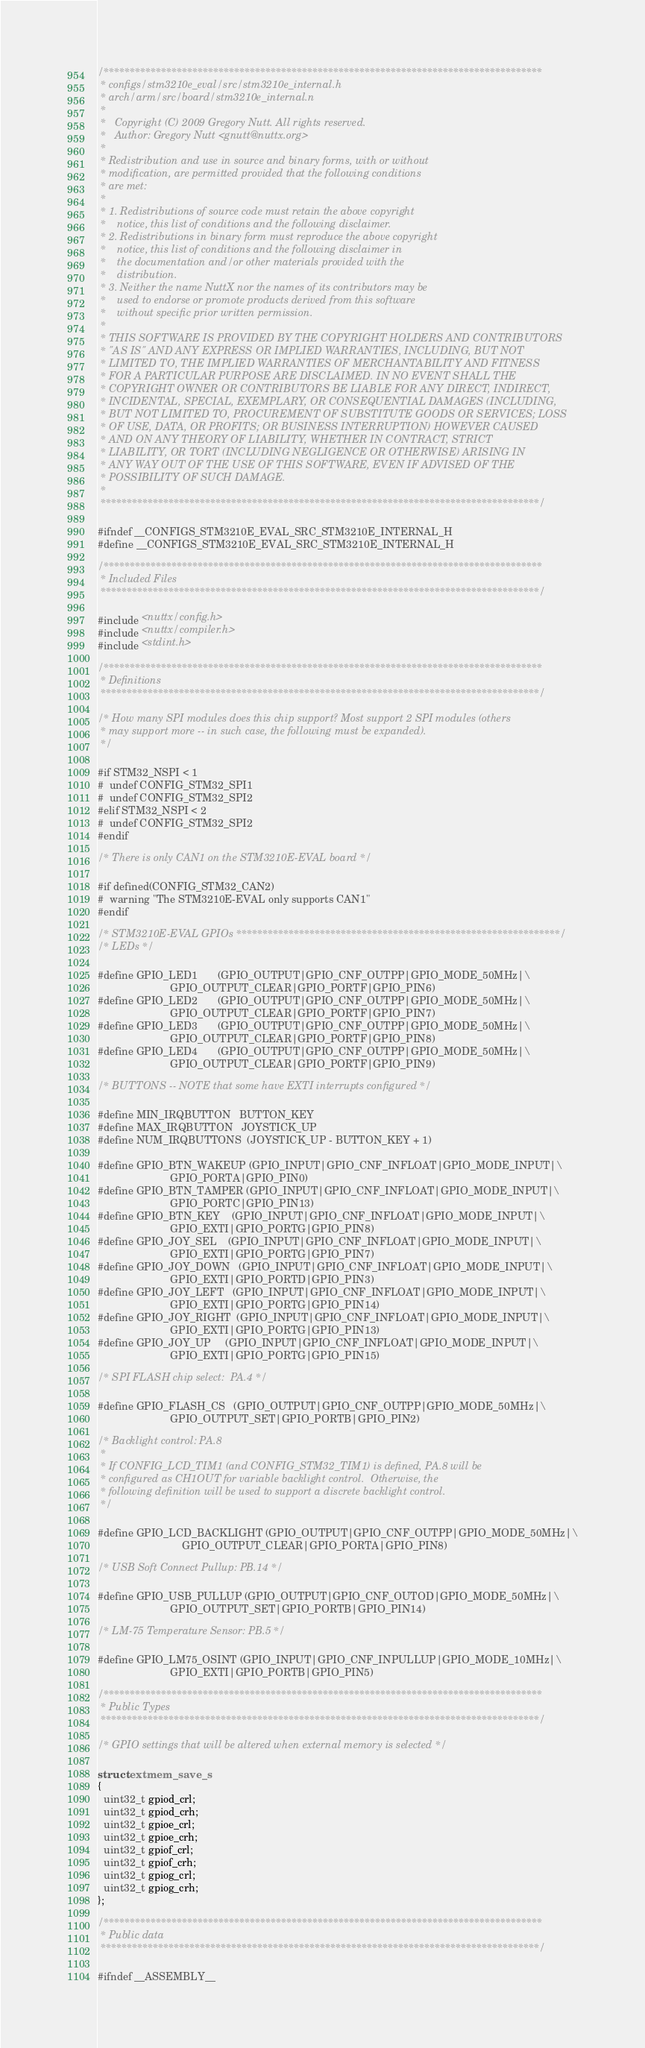<code> <loc_0><loc_0><loc_500><loc_500><_C_>/************************************************************************************
 * configs/stm3210e_eval/src/stm3210e_internal.h
 * arch/arm/src/board/stm3210e_internal.n
 *
 *   Copyright (C) 2009 Gregory Nutt. All rights reserved.
 *   Author: Gregory Nutt <gnutt@nuttx.org>
 *
 * Redistribution and use in source and binary forms, with or without
 * modification, are permitted provided that the following conditions
 * are met:
 *
 * 1. Redistributions of source code must retain the above copyright
 *    notice, this list of conditions and the following disclaimer.
 * 2. Redistributions in binary form must reproduce the above copyright
 *    notice, this list of conditions and the following disclaimer in
 *    the documentation and/or other materials provided with the
 *    distribution.
 * 3. Neither the name NuttX nor the names of its contributors may be
 *    used to endorse or promote products derived from this software
 *    without specific prior written permission.
 *
 * THIS SOFTWARE IS PROVIDED BY THE COPYRIGHT HOLDERS AND CONTRIBUTORS
 * "AS IS" AND ANY EXPRESS OR IMPLIED WARRANTIES, INCLUDING, BUT NOT
 * LIMITED TO, THE IMPLIED WARRANTIES OF MERCHANTABILITY AND FITNESS
 * FOR A PARTICULAR PURPOSE ARE DISCLAIMED. IN NO EVENT SHALL THE
 * COPYRIGHT OWNER OR CONTRIBUTORS BE LIABLE FOR ANY DIRECT, INDIRECT,
 * INCIDENTAL, SPECIAL, EXEMPLARY, OR CONSEQUENTIAL DAMAGES (INCLUDING,
 * BUT NOT LIMITED TO, PROCUREMENT OF SUBSTITUTE GOODS OR SERVICES; LOSS
 * OF USE, DATA, OR PROFITS; OR BUSINESS INTERRUPTION) HOWEVER CAUSED
 * AND ON ANY THEORY OF LIABILITY, WHETHER IN CONTRACT, STRICT
 * LIABILITY, OR TORT (INCLUDING NEGLIGENCE OR OTHERWISE) ARISING IN
 * ANY WAY OUT OF THE USE OF THIS SOFTWARE, EVEN IF ADVISED OF THE
 * POSSIBILITY OF SUCH DAMAGE.
 *
 ************************************************************************************/

#ifndef __CONFIGS_STM3210E_EVAL_SRC_STM3210E_INTERNAL_H
#define __CONFIGS_STM3210E_EVAL_SRC_STM3210E_INTERNAL_H

/************************************************************************************
 * Included Files
 ************************************************************************************/

#include <nuttx/config.h>
#include <nuttx/compiler.h>
#include <stdint.h>

/************************************************************************************
 * Definitions
 ************************************************************************************/

/* How many SPI modules does this chip support? Most support 2 SPI modules (others
 * may support more -- in such case, the following must be expanded).
 */

#if STM32_NSPI < 1
#  undef CONFIG_STM32_SPI1
#  undef CONFIG_STM32_SPI2
#elif STM32_NSPI < 2
#  undef CONFIG_STM32_SPI2
#endif

/* There is only CAN1 on the STM3210E-EVAL board */

#if defined(CONFIG_STM32_CAN2)
#  warning "The STM3210E-EVAL only supports CAN1"
#endif

/* STM3210E-EVAL GPIOs **************************************************************/
/* LEDs */

#define GPIO_LED1       (GPIO_OUTPUT|GPIO_CNF_OUTPP|GPIO_MODE_50MHz|\
                         GPIO_OUTPUT_CLEAR|GPIO_PORTF|GPIO_PIN6)
#define GPIO_LED2       (GPIO_OUTPUT|GPIO_CNF_OUTPP|GPIO_MODE_50MHz|\
                         GPIO_OUTPUT_CLEAR|GPIO_PORTF|GPIO_PIN7)
#define GPIO_LED3       (GPIO_OUTPUT|GPIO_CNF_OUTPP|GPIO_MODE_50MHz|\
                         GPIO_OUTPUT_CLEAR|GPIO_PORTF|GPIO_PIN8)
#define GPIO_LED4       (GPIO_OUTPUT|GPIO_CNF_OUTPP|GPIO_MODE_50MHz|\
                         GPIO_OUTPUT_CLEAR|GPIO_PORTF|GPIO_PIN9)

/* BUTTONS -- NOTE that some have EXTI interrupts configured */

#define MIN_IRQBUTTON   BUTTON_KEY
#define MAX_IRQBUTTON   JOYSTICK_UP
#define NUM_IRQBUTTONS  (JOYSTICK_UP - BUTTON_KEY + 1)

#define GPIO_BTN_WAKEUP (GPIO_INPUT|GPIO_CNF_INFLOAT|GPIO_MODE_INPUT|\
                         GPIO_PORTA|GPIO_PIN0)
#define GPIO_BTN_TAMPER (GPIO_INPUT|GPIO_CNF_INFLOAT|GPIO_MODE_INPUT|\
                         GPIO_PORTC|GPIO_PIN13)
#define GPIO_BTN_KEY    (GPIO_INPUT|GPIO_CNF_INFLOAT|GPIO_MODE_INPUT|\
                         GPIO_EXTI|GPIO_PORTG|GPIO_PIN8)
#define GPIO_JOY_SEL    (GPIO_INPUT|GPIO_CNF_INFLOAT|GPIO_MODE_INPUT|\
                         GPIO_EXTI|GPIO_PORTG|GPIO_PIN7)
#define GPIO_JOY_DOWN   (GPIO_INPUT|GPIO_CNF_INFLOAT|GPIO_MODE_INPUT|\
                         GPIO_EXTI|GPIO_PORTD|GPIO_PIN3)
#define GPIO_JOY_LEFT   (GPIO_INPUT|GPIO_CNF_INFLOAT|GPIO_MODE_INPUT|\
                         GPIO_EXTI|GPIO_PORTG|GPIO_PIN14)
#define GPIO_JOY_RIGHT  (GPIO_INPUT|GPIO_CNF_INFLOAT|GPIO_MODE_INPUT|\
                         GPIO_EXTI|GPIO_PORTG|GPIO_PIN13)
#define GPIO_JOY_UP     (GPIO_INPUT|GPIO_CNF_INFLOAT|GPIO_MODE_INPUT|\
                         GPIO_EXTI|GPIO_PORTG|GPIO_PIN15)

/* SPI FLASH chip select:  PA.4 */

#define GPIO_FLASH_CS   (GPIO_OUTPUT|GPIO_CNF_OUTPP|GPIO_MODE_50MHz|\
                         GPIO_OUTPUT_SET|GPIO_PORTB|GPIO_PIN2)

/* Backlight control: PA.8
 *
 * If CONFIG_LCD_TIM1 (and CONFIG_STM32_TIM1) is defined, PA.8 will be
 * configured as CH1OUT for variable backlight control.  Otherwise, the
 * following definition will be used to support a discrete backlight control.
 */
 
#define GPIO_LCD_BACKLIGHT (GPIO_OUTPUT|GPIO_CNF_OUTPP|GPIO_MODE_50MHz|\
                             GPIO_OUTPUT_CLEAR|GPIO_PORTA|GPIO_PIN8)

/* USB Soft Connect Pullup: PB.14 */

#define GPIO_USB_PULLUP (GPIO_OUTPUT|GPIO_CNF_OUTOD|GPIO_MODE_50MHz|\
                         GPIO_OUTPUT_SET|GPIO_PORTB|GPIO_PIN14)

/* LM-75 Temperature Sensor: PB.5 */

#define GPIO_LM75_OSINT (GPIO_INPUT|GPIO_CNF_INPULLUP|GPIO_MODE_10MHz|\
                         GPIO_EXTI|GPIO_PORTB|GPIO_PIN5)

/************************************************************************************
 * Public Types
 ************************************************************************************/

/* GPIO settings that will be altered when external memory is selected */

struct extmem_save_s
{
  uint32_t gpiod_crl;
  uint32_t gpiod_crh;
  uint32_t gpioe_crl;
  uint32_t gpioe_crh;
  uint32_t gpiof_crl;
  uint32_t gpiof_crh;
  uint32_t gpiog_crl;
  uint32_t gpiog_crh;
};

/************************************************************************************
 * Public data
 ************************************************************************************/

#ifndef __ASSEMBLY__
</code> 